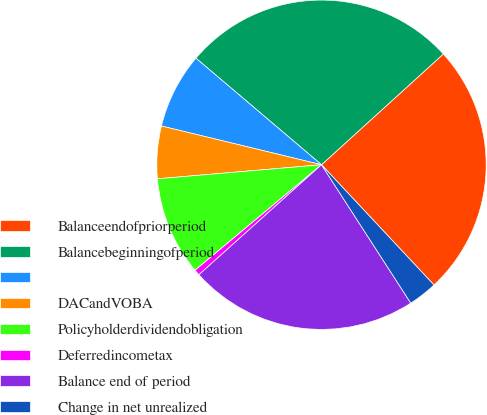<chart> <loc_0><loc_0><loc_500><loc_500><pie_chart><fcel>Balanceendofpriorperiod<fcel>Balancebeginningofperiod<fcel>Unnamed: 2<fcel>DACandVOBA<fcel>Policyholderdividendobligation<fcel>Deferredincometax<fcel>Balance end of period<fcel>Change in net unrealized<nl><fcel>24.77%<fcel>27.06%<fcel>7.42%<fcel>5.14%<fcel>9.71%<fcel>0.57%<fcel>22.48%<fcel>2.85%<nl></chart> 